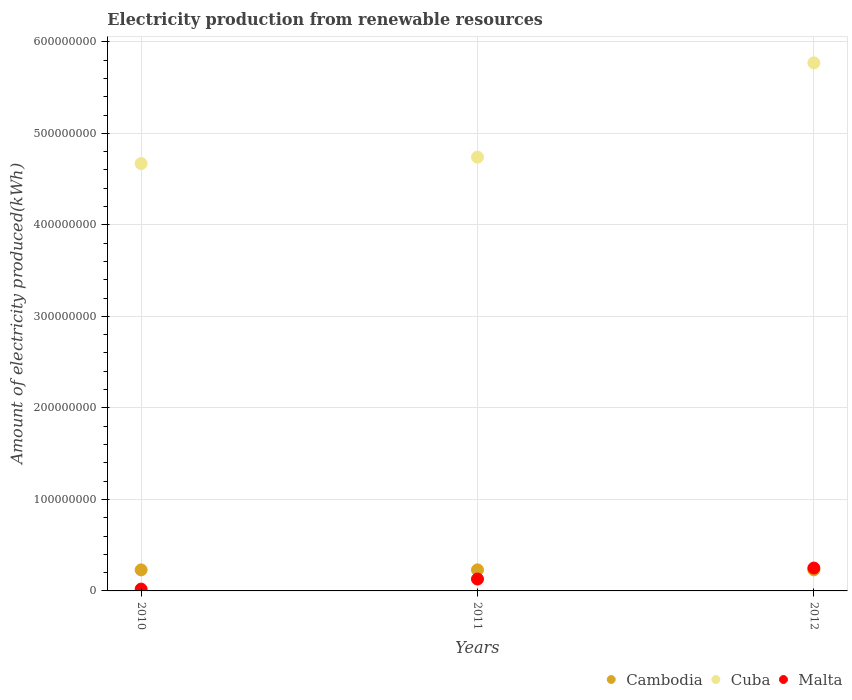Is the number of dotlines equal to the number of legend labels?
Your response must be concise. Yes. What is the amount of electricity produced in Cambodia in 2010?
Give a very brief answer. 2.30e+07. Across all years, what is the maximum amount of electricity produced in Cuba?
Your answer should be very brief. 5.77e+08. Across all years, what is the minimum amount of electricity produced in Cuba?
Make the answer very short. 4.67e+08. In which year was the amount of electricity produced in Cuba maximum?
Provide a succinct answer. 2012. What is the total amount of electricity produced in Malta in the graph?
Your answer should be compact. 4.00e+07. What is the difference between the amount of electricity produced in Cambodia in 2011 and the amount of electricity produced in Malta in 2012?
Keep it short and to the point. -2.00e+06. What is the average amount of electricity produced in Cuba per year?
Offer a very short reply. 5.06e+08. In the year 2010, what is the difference between the amount of electricity produced in Cuba and amount of electricity produced in Malta?
Provide a succinct answer. 4.65e+08. In how many years, is the amount of electricity produced in Cambodia greater than 300000000 kWh?
Keep it short and to the point. 0. What is the ratio of the amount of electricity produced in Cuba in 2010 to that in 2012?
Your answer should be compact. 0.81. Is the amount of electricity produced in Malta in 2011 less than that in 2012?
Offer a very short reply. Yes. What is the difference between the highest and the second highest amount of electricity produced in Malta?
Give a very brief answer. 1.20e+07. What is the difference between the highest and the lowest amount of electricity produced in Malta?
Your answer should be compact. 2.30e+07. In how many years, is the amount of electricity produced in Cuba greater than the average amount of electricity produced in Cuba taken over all years?
Provide a short and direct response. 1. Is the sum of the amount of electricity produced in Cambodia in 2010 and 2011 greater than the maximum amount of electricity produced in Cuba across all years?
Offer a very short reply. No. Is the amount of electricity produced in Cambodia strictly less than the amount of electricity produced in Cuba over the years?
Provide a short and direct response. Yes. Are the values on the major ticks of Y-axis written in scientific E-notation?
Make the answer very short. No. Does the graph contain any zero values?
Make the answer very short. No. Does the graph contain grids?
Offer a very short reply. Yes. Where does the legend appear in the graph?
Make the answer very short. Bottom right. How many legend labels are there?
Provide a succinct answer. 3. What is the title of the graph?
Offer a terse response. Electricity production from renewable resources. What is the label or title of the Y-axis?
Provide a succinct answer. Amount of electricity produced(kWh). What is the Amount of electricity produced(kWh) of Cambodia in 2010?
Give a very brief answer. 2.30e+07. What is the Amount of electricity produced(kWh) of Cuba in 2010?
Offer a terse response. 4.67e+08. What is the Amount of electricity produced(kWh) of Cambodia in 2011?
Give a very brief answer. 2.30e+07. What is the Amount of electricity produced(kWh) of Cuba in 2011?
Make the answer very short. 4.74e+08. What is the Amount of electricity produced(kWh) of Malta in 2011?
Offer a very short reply. 1.30e+07. What is the Amount of electricity produced(kWh) of Cambodia in 2012?
Offer a very short reply. 2.30e+07. What is the Amount of electricity produced(kWh) in Cuba in 2012?
Make the answer very short. 5.77e+08. What is the Amount of electricity produced(kWh) of Malta in 2012?
Your response must be concise. 2.50e+07. Across all years, what is the maximum Amount of electricity produced(kWh) in Cambodia?
Provide a short and direct response. 2.30e+07. Across all years, what is the maximum Amount of electricity produced(kWh) in Cuba?
Your answer should be compact. 5.77e+08. Across all years, what is the maximum Amount of electricity produced(kWh) in Malta?
Keep it short and to the point. 2.50e+07. Across all years, what is the minimum Amount of electricity produced(kWh) of Cambodia?
Your answer should be compact. 2.30e+07. Across all years, what is the minimum Amount of electricity produced(kWh) in Cuba?
Your response must be concise. 4.67e+08. Across all years, what is the minimum Amount of electricity produced(kWh) of Malta?
Your answer should be very brief. 2.00e+06. What is the total Amount of electricity produced(kWh) of Cambodia in the graph?
Provide a succinct answer. 6.90e+07. What is the total Amount of electricity produced(kWh) in Cuba in the graph?
Keep it short and to the point. 1.52e+09. What is the total Amount of electricity produced(kWh) in Malta in the graph?
Make the answer very short. 4.00e+07. What is the difference between the Amount of electricity produced(kWh) of Cambodia in 2010 and that in 2011?
Offer a terse response. 0. What is the difference between the Amount of electricity produced(kWh) in Cuba in 2010 and that in 2011?
Your answer should be compact. -7.00e+06. What is the difference between the Amount of electricity produced(kWh) in Malta in 2010 and that in 2011?
Your answer should be compact. -1.10e+07. What is the difference between the Amount of electricity produced(kWh) of Cambodia in 2010 and that in 2012?
Provide a short and direct response. 0. What is the difference between the Amount of electricity produced(kWh) in Cuba in 2010 and that in 2012?
Offer a very short reply. -1.10e+08. What is the difference between the Amount of electricity produced(kWh) of Malta in 2010 and that in 2012?
Provide a short and direct response. -2.30e+07. What is the difference between the Amount of electricity produced(kWh) of Cambodia in 2011 and that in 2012?
Offer a terse response. 0. What is the difference between the Amount of electricity produced(kWh) of Cuba in 2011 and that in 2012?
Offer a terse response. -1.03e+08. What is the difference between the Amount of electricity produced(kWh) in Malta in 2011 and that in 2012?
Give a very brief answer. -1.20e+07. What is the difference between the Amount of electricity produced(kWh) in Cambodia in 2010 and the Amount of electricity produced(kWh) in Cuba in 2011?
Provide a succinct answer. -4.51e+08. What is the difference between the Amount of electricity produced(kWh) of Cambodia in 2010 and the Amount of electricity produced(kWh) of Malta in 2011?
Make the answer very short. 1.00e+07. What is the difference between the Amount of electricity produced(kWh) in Cuba in 2010 and the Amount of electricity produced(kWh) in Malta in 2011?
Ensure brevity in your answer.  4.54e+08. What is the difference between the Amount of electricity produced(kWh) in Cambodia in 2010 and the Amount of electricity produced(kWh) in Cuba in 2012?
Provide a short and direct response. -5.54e+08. What is the difference between the Amount of electricity produced(kWh) of Cuba in 2010 and the Amount of electricity produced(kWh) of Malta in 2012?
Provide a short and direct response. 4.42e+08. What is the difference between the Amount of electricity produced(kWh) of Cambodia in 2011 and the Amount of electricity produced(kWh) of Cuba in 2012?
Your answer should be compact. -5.54e+08. What is the difference between the Amount of electricity produced(kWh) in Cuba in 2011 and the Amount of electricity produced(kWh) in Malta in 2012?
Offer a terse response. 4.49e+08. What is the average Amount of electricity produced(kWh) of Cambodia per year?
Provide a succinct answer. 2.30e+07. What is the average Amount of electricity produced(kWh) in Cuba per year?
Your answer should be very brief. 5.06e+08. What is the average Amount of electricity produced(kWh) of Malta per year?
Your answer should be compact. 1.33e+07. In the year 2010, what is the difference between the Amount of electricity produced(kWh) in Cambodia and Amount of electricity produced(kWh) in Cuba?
Offer a very short reply. -4.44e+08. In the year 2010, what is the difference between the Amount of electricity produced(kWh) in Cambodia and Amount of electricity produced(kWh) in Malta?
Your response must be concise. 2.10e+07. In the year 2010, what is the difference between the Amount of electricity produced(kWh) in Cuba and Amount of electricity produced(kWh) in Malta?
Offer a terse response. 4.65e+08. In the year 2011, what is the difference between the Amount of electricity produced(kWh) of Cambodia and Amount of electricity produced(kWh) of Cuba?
Your response must be concise. -4.51e+08. In the year 2011, what is the difference between the Amount of electricity produced(kWh) of Cuba and Amount of electricity produced(kWh) of Malta?
Offer a terse response. 4.61e+08. In the year 2012, what is the difference between the Amount of electricity produced(kWh) in Cambodia and Amount of electricity produced(kWh) in Cuba?
Ensure brevity in your answer.  -5.54e+08. In the year 2012, what is the difference between the Amount of electricity produced(kWh) of Cambodia and Amount of electricity produced(kWh) of Malta?
Your response must be concise. -2.00e+06. In the year 2012, what is the difference between the Amount of electricity produced(kWh) of Cuba and Amount of electricity produced(kWh) of Malta?
Give a very brief answer. 5.52e+08. What is the ratio of the Amount of electricity produced(kWh) in Cuba in 2010 to that in 2011?
Your response must be concise. 0.99. What is the ratio of the Amount of electricity produced(kWh) in Malta in 2010 to that in 2011?
Offer a very short reply. 0.15. What is the ratio of the Amount of electricity produced(kWh) of Cuba in 2010 to that in 2012?
Give a very brief answer. 0.81. What is the ratio of the Amount of electricity produced(kWh) in Cuba in 2011 to that in 2012?
Your answer should be very brief. 0.82. What is the ratio of the Amount of electricity produced(kWh) in Malta in 2011 to that in 2012?
Offer a very short reply. 0.52. What is the difference between the highest and the second highest Amount of electricity produced(kWh) in Cuba?
Provide a short and direct response. 1.03e+08. What is the difference between the highest and the lowest Amount of electricity produced(kWh) in Cambodia?
Your answer should be very brief. 0. What is the difference between the highest and the lowest Amount of electricity produced(kWh) in Cuba?
Your answer should be very brief. 1.10e+08. What is the difference between the highest and the lowest Amount of electricity produced(kWh) in Malta?
Your response must be concise. 2.30e+07. 